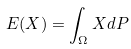<formula> <loc_0><loc_0><loc_500><loc_500>E ( X ) = \int _ { \Omega } X d P</formula> 